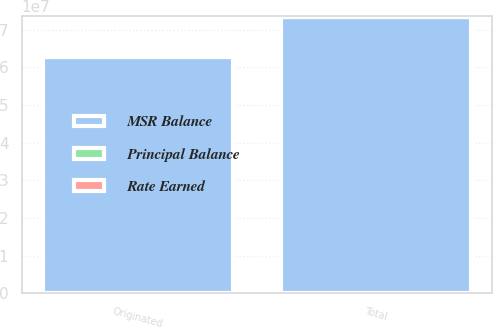Convert chart. <chart><loc_0><loc_0><loc_500><loc_500><stacked_bar_chart><ecel><fcel>Originated<fcel>Total<nl><fcel>MSR Balance<fcel>6.28138e+07<fcel>7.33821e+07<nl><fcel>Principal Balance<fcel>272472<fcel>272472<nl><fcel>Rate Earned<fcel>0.38<fcel>0.38<nl></chart> 